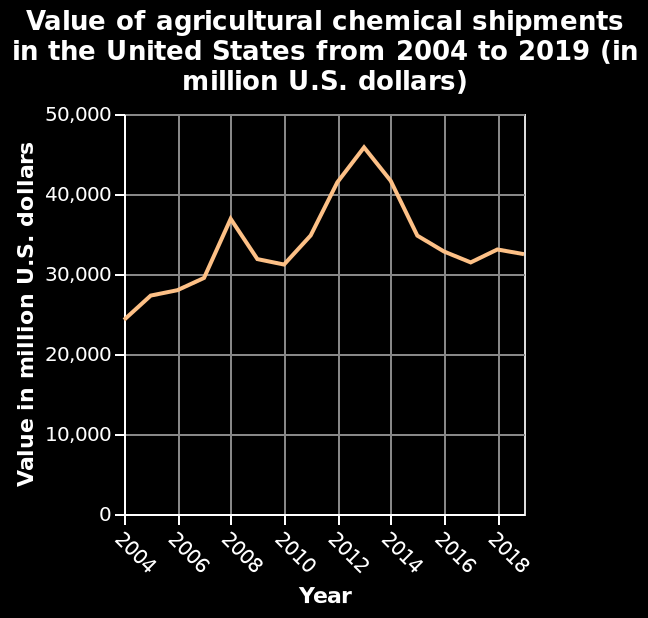<image>
What is represented on the y-axis of the line chart?  The value of agricultural chemical shipments in million U.S. dollars is represented on the y-axis of the line chart. Offer a thorough analysis of the image. in 2004 the value of US agricultural chemical shipments was around USD25bn.  The value increased steadily to USD30bn in 2007.  A sharp increase was seen in 2008 to USD37bn.  The value declined in 2009 -2010 to around USD31bn.  There was a steady rise to a peak in 2013 of USD46bn.  This dropped back sharply to USD31bn in 2017.  A small rise to USD32bn took place between 2017 and 2019. What is the unit of measurement used for the value of agricultural chemical shipments?  The unit of measurement used for the value of agricultural chemical shipments is million U.S. dollars. 